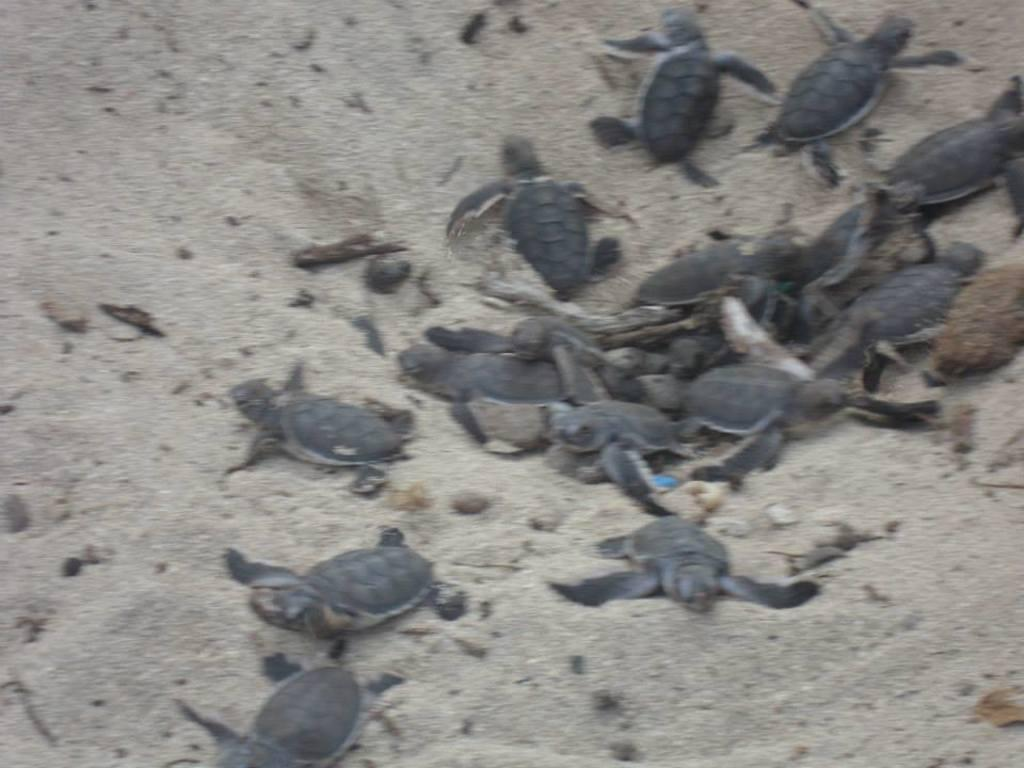What type of animals are in the picture? There are tortoises in the picture. What is the surface on which the tortoises are located? The tortoises are on the sand. What color is the yarn that the tortoises are using to knit in the picture? There is no yarn or knitting activity present in the image; the tortoises are simply on the sand. 